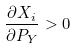<formula> <loc_0><loc_0><loc_500><loc_500>\frac { \partial X _ { i } } { \partial P _ { Y } } > 0</formula> 